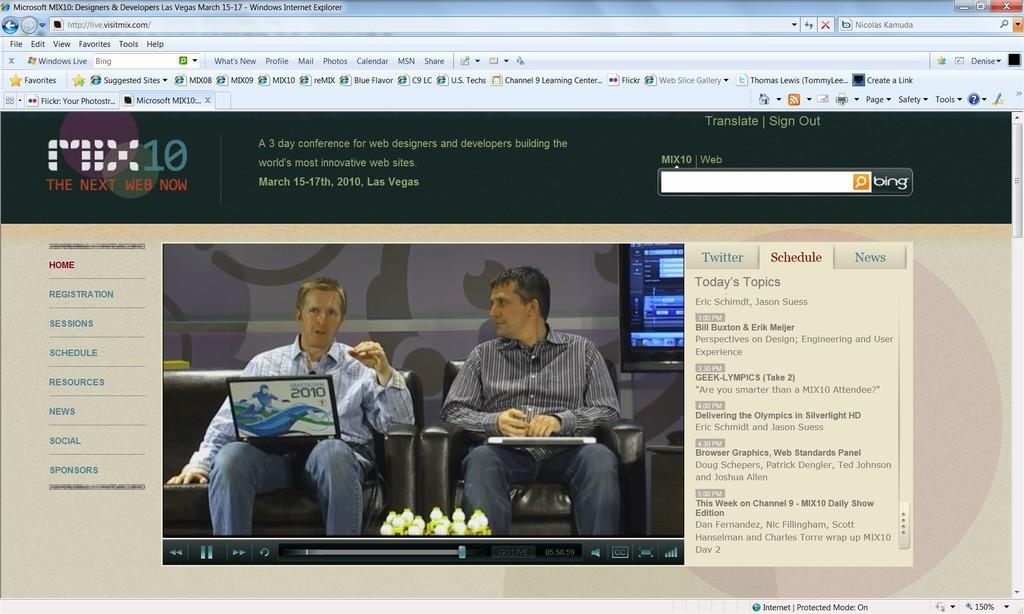Describe this image in one or two sentences. This is a picture of web page. We can see men sitting on the chairs and we can see laptops. 